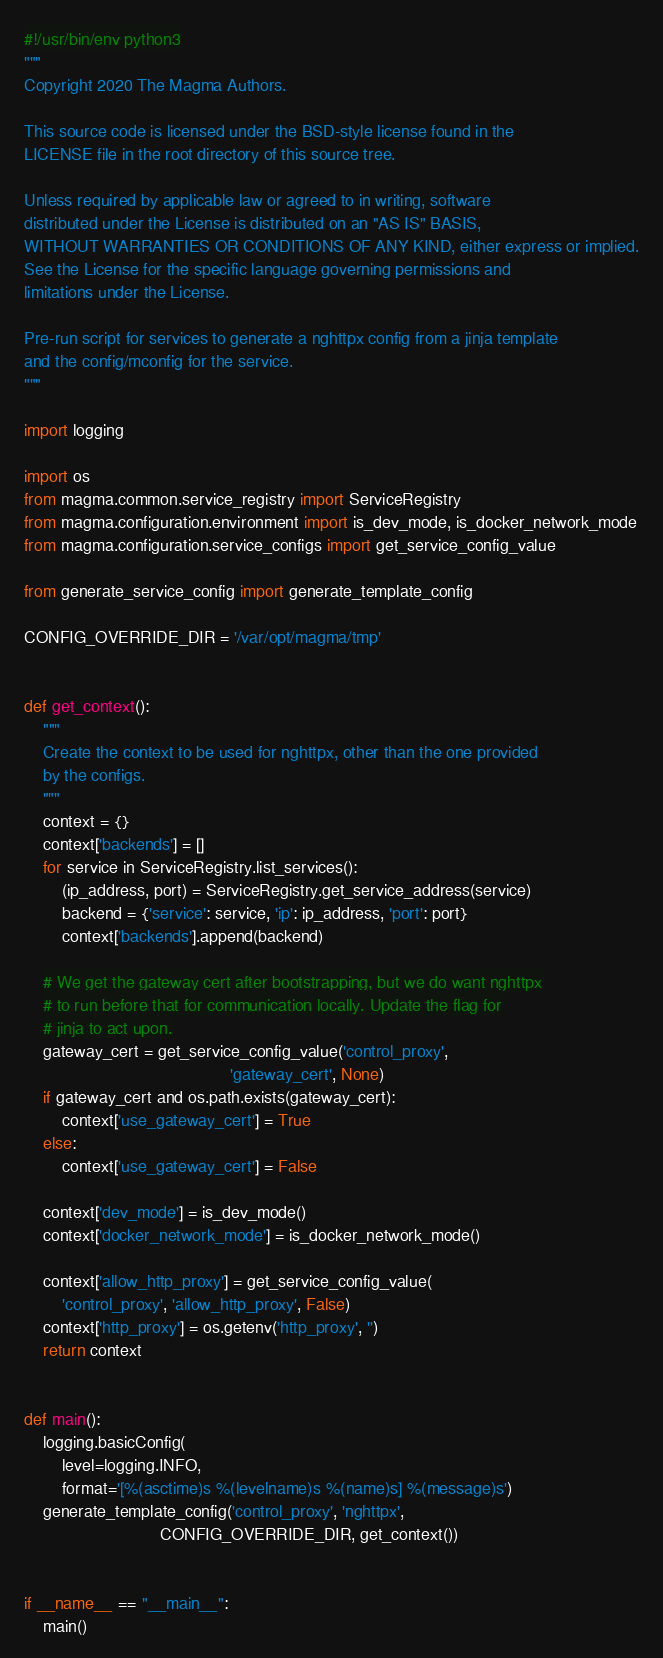<code> <loc_0><loc_0><loc_500><loc_500><_Python_>#!/usr/bin/env python3
"""
Copyright 2020 The Magma Authors.

This source code is licensed under the BSD-style license found in the
LICENSE file in the root directory of this source tree.

Unless required by applicable law or agreed to in writing, software
distributed under the License is distributed on an "AS IS" BASIS,
WITHOUT WARRANTIES OR CONDITIONS OF ANY KIND, either express or implied.
See the License for the specific language governing permissions and
limitations under the License.

Pre-run script for services to generate a nghttpx config from a jinja template
and the config/mconfig for the service.
"""

import logging

import os
from magma.common.service_registry import ServiceRegistry
from magma.configuration.environment import is_dev_mode, is_docker_network_mode
from magma.configuration.service_configs import get_service_config_value

from generate_service_config import generate_template_config

CONFIG_OVERRIDE_DIR = '/var/opt/magma/tmp'


def get_context():
    """
    Create the context to be used for nghttpx, other than the one provided
    by the configs.
    """
    context = {}
    context['backends'] = []
    for service in ServiceRegistry.list_services():
        (ip_address, port) = ServiceRegistry.get_service_address(service)
        backend = {'service': service, 'ip': ip_address, 'port': port}
        context['backends'].append(backend)

    # We get the gateway cert after bootstrapping, but we do want nghttpx
    # to run before that for communication locally. Update the flag for
    # jinja to act upon.
    gateway_cert = get_service_config_value('control_proxy',
                                            'gateway_cert', None)
    if gateway_cert and os.path.exists(gateway_cert):
        context['use_gateway_cert'] = True
    else:
        context['use_gateway_cert'] = False

    context['dev_mode'] = is_dev_mode()
    context['docker_network_mode'] = is_docker_network_mode()

    context['allow_http_proxy'] = get_service_config_value(
        'control_proxy', 'allow_http_proxy', False)
    context['http_proxy'] = os.getenv('http_proxy', '')
    return context


def main():
    logging.basicConfig(
        level=logging.INFO,
        format='[%(asctime)s %(levelname)s %(name)s] %(message)s')
    generate_template_config('control_proxy', 'nghttpx',
                             CONFIG_OVERRIDE_DIR, get_context())


if __name__ == "__main__":
    main()
</code> 